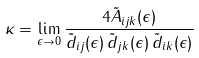<formula> <loc_0><loc_0><loc_500><loc_500>\kappa = \lim _ { \epsilon \to 0 } \frac { 4 \tilde { A } _ { i j k } ( \epsilon ) } { \tilde { d } _ { i j } ( \epsilon ) \, \tilde { d } _ { j k } ( \epsilon ) \, \tilde { d } _ { i k } ( \epsilon ) }</formula> 